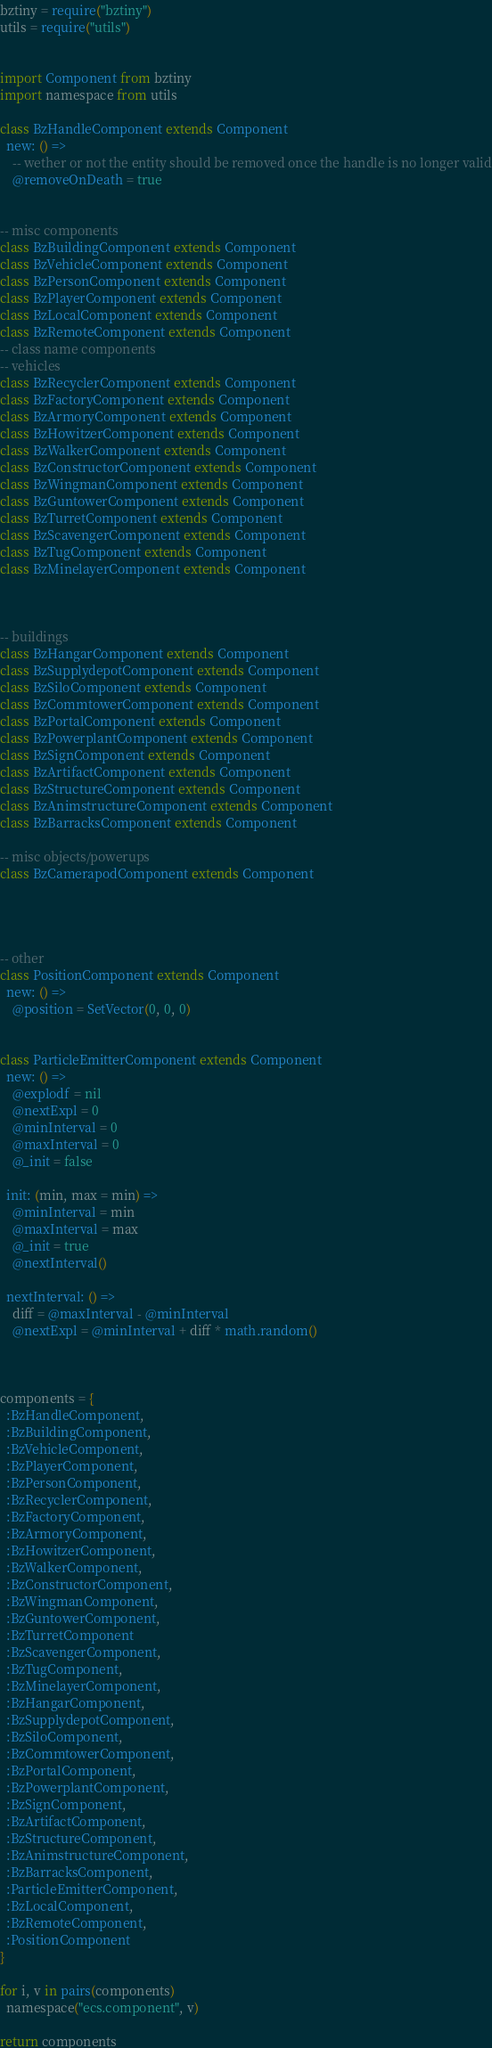<code> <loc_0><loc_0><loc_500><loc_500><_MoonScript_>
bztiny = require("bztiny")
utils = require("utils")


import Component from bztiny
import namespace from utils

class BzHandleComponent extends Component
  new: () =>
    -- wether or not the entity should be removed once the handle is no longer valid
    @removeOnDeath = true


-- misc components
class BzBuildingComponent extends Component
class BzVehicleComponent extends Component
class BzPersonComponent extends Component
class BzPlayerComponent extends Component
class BzLocalComponent extends Component
class BzRemoteComponent extends Component
-- class name components
-- vehicles
class BzRecyclerComponent extends Component
class BzFactoryComponent extends Component
class BzArmoryComponent extends Component
class BzHowitzerComponent extends Component
class BzWalkerComponent extends Component
class BzConstructorComponent extends Component
class BzWingmanComponent extends Component
class BzGuntowerComponent extends Component
class BzTurretComponent extends Component
class BzScavengerComponent extends Component
class BzTugComponent extends Component
class BzMinelayerComponent extends Component



-- buildings
class BzHangarComponent extends Component
class BzSupplydepotComponent extends Component
class BzSiloComponent extends Component
class BzCommtowerComponent extends Component
class BzPortalComponent extends Component
class BzPowerplantComponent extends Component
class BzSignComponent extends Component
class BzArtifactComponent extends Component
class BzStructureComponent extends Component
class BzAnimstructureComponent extends Component
class BzBarracksComponent extends Component

-- misc objects/powerups
class BzCamerapodComponent extends Component




-- other
class PositionComponent extends Component
  new: () =>
    @position = SetVector(0, 0, 0)


class ParticleEmitterComponent extends Component
  new: () =>
    @explodf = nil
    @nextExpl = 0
    @minInterval = 0
    @maxInterval = 0
    @_init = false
  
  init: (min, max = min) =>
    @minInterval = min
    @maxInterval = max
    @_init = true
    @nextInterval()

  nextInterval: () =>
    diff = @maxInterval - @minInterval
    @nextExpl = @minInterval + diff * math.random()
      


components = {
  :BzHandleComponent,
  :BzBuildingComponent,
  :BzVehicleComponent,
  :BzPlayerComponent,
  :BzPersonComponent,
  :BzRecyclerComponent,
  :BzFactoryComponent,
  :BzArmoryComponent,
  :BzHowitzerComponent,
  :BzWalkerComponent,
  :BzConstructorComponent,
  :BzWingmanComponent,
  :BzGuntowerComponent,
  :BzTurretComponent
  :BzScavengerComponent,
  :BzTugComponent,
  :BzMinelayerComponent,
  :BzHangarComponent,
  :BzSupplydepotComponent,
  :BzSiloComponent,
  :BzCommtowerComponent,
  :BzPortalComponent,
  :BzPowerplantComponent,
  :BzSignComponent,
  :BzArtifactComponent,
  :BzStructureComponent,
  :BzAnimstructureComponent,
  :BzBarracksComponent,
  :ParticleEmitterComponent,
  :BzLocalComponent,
  :BzRemoteComponent,
  :PositionComponent
}

for i, v in pairs(components)
  namespace("ecs.component", v)

return components
</code> 